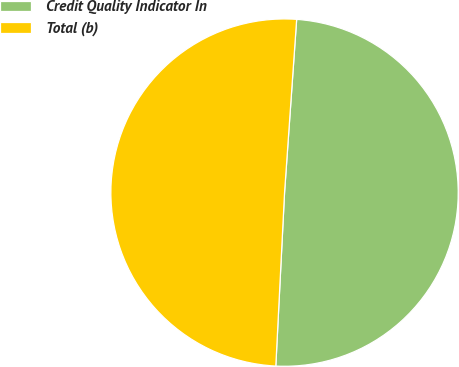Convert chart to OTSL. <chart><loc_0><loc_0><loc_500><loc_500><pie_chart><fcel>Credit Quality Indicator In<fcel>Total (b)<nl><fcel>49.69%<fcel>50.31%<nl></chart> 